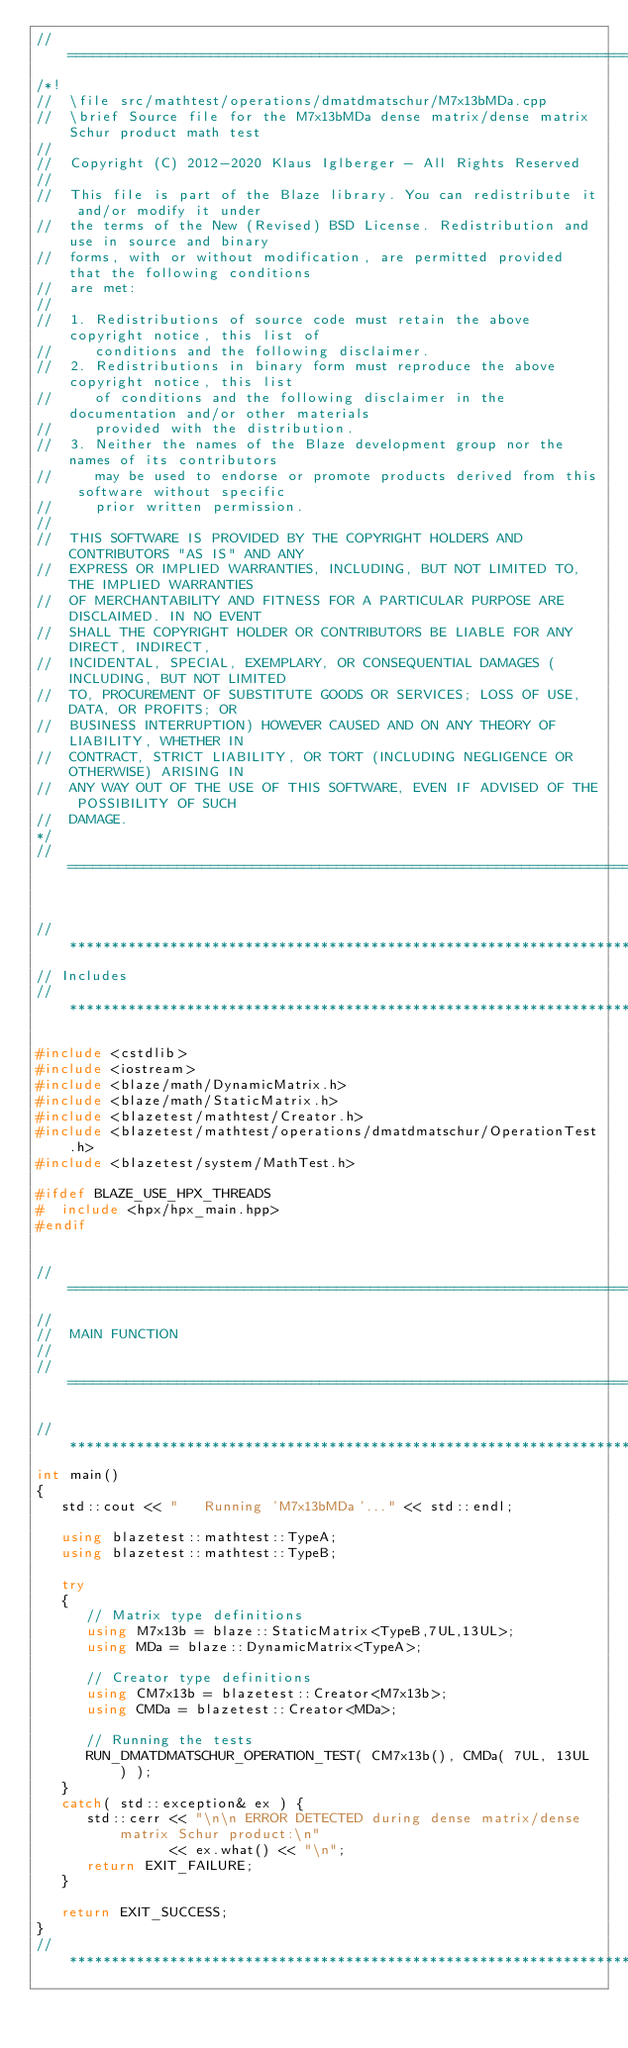Convert code to text. <code><loc_0><loc_0><loc_500><loc_500><_C++_>//=================================================================================================
/*!
//  \file src/mathtest/operations/dmatdmatschur/M7x13bMDa.cpp
//  \brief Source file for the M7x13bMDa dense matrix/dense matrix Schur product math test
//
//  Copyright (C) 2012-2020 Klaus Iglberger - All Rights Reserved
//
//  This file is part of the Blaze library. You can redistribute it and/or modify it under
//  the terms of the New (Revised) BSD License. Redistribution and use in source and binary
//  forms, with or without modification, are permitted provided that the following conditions
//  are met:
//
//  1. Redistributions of source code must retain the above copyright notice, this list of
//     conditions and the following disclaimer.
//  2. Redistributions in binary form must reproduce the above copyright notice, this list
//     of conditions and the following disclaimer in the documentation and/or other materials
//     provided with the distribution.
//  3. Neither the names of the Blaze development group nor the names of its contributors
//     may be used to endorse or promote products derived from this software without specific
//     prior written permission.
//
//  THIS SOFTWARE IS PROVIDED BY THE COPYRIGHT HOLDERS AND CONTRIBUTORS "AS IS" AND ANY
//  EXPRESS OR IMPLIED WARRANTIES, INCLUDING, BUT NOT LIMITED TO, THE IMPLIED WARRANTIES
//  OF MERCHANTABILITY AND FITNESS FOR A PARTICULAR PURPOSE ARE DISCLAIMED. IN NO EVENT
//  SHALL THE COPYRIGHT HOLDER OR CONTRIBUTORS BE LIABLE FOR ANY DIRECT, INDIRECT,
//  INCIDENTAL, SPECIAL, EXEMPLARY, OR CONSEQUENTIAL DAMAGES (INCLUDING, BUT NOT LIMITED
//  TO, PROCUREMENT OF SUBSTITUTE GOODS OR SERVICES; LOSS OF USE, DATA, OR PROFITS; OR
//  BUSINESS INTERRUPTION) HOWEVER CAUSED AND ON ANY THEORY OF LIABILITY, WHETHER IN
//  CONTRACT, STRICT LIABILITY, OR TORT (INCLUDING NEGLIGENCE OR OTHERWISE) ARISING IN
//  ANY WAY OUT OF THE USE OF THIS SOFTWARE, EVEN IF ADVISED OF THE POSSIBILITY OF SUCH
//  DAMAGE.
*/
//=================================================================================================


//*************************************************************************************************
// Includes
//*************************************************************************************************

#include <cstdlib>
#include <iostream>
#include <blaze/math/DynamicMatrix.h>
#include <blaze/math/StaticMatrix.h>
#include <blazetest/mathtest/Creator.h>
#include <blazetest/mathtest/operations/dmatdmatschur/OperationTest.h>
#include <blazetest/system/MathTest.h>

#ifdef BLAZE_USE_HPX_THREADS
#  include <hpx/hpx_main.hpp>
#endif


//=================================================================================================
//
//  MAIN FUNCTION
//
//=================================================================================================

//*************************************************************************************************
int main()
{
   std::cout << "   Running 'M7x13bMDa'..." << std::endl;

   using blazetest::mathtest::TypeA;
   using blazetest::mathtest::TypeB;

   try
   {
      // Matrix type definitions
      using M7x13b = blaze::StaticMatrix<TypeB,7UL,13UL>;
      using MDa = blaze::DynamicMatrix<TypeA>;

      // Creator type definitions
      using CM7x13b = blazetest::Creator<M7x13b>;
      using CMDa = blazetest::Creator<MDa>;

      // Running the tests
      RUN_DMATDMATSCHUR_OPERATION_TEST( CM7x13b(), CMDa( 7UL, 13UL ) );
   }
   catch( std::exception& ex ) {
      std::cerr << "\n\n ERROR DETECTED during dense matrix/dense matrix Schur product:\n"
                << ex.what() << "\n";
      return EXIT_FAILURE;
   }

   return EXIT_SUCCESS;
}
//*************************************************************************************************
</code> 